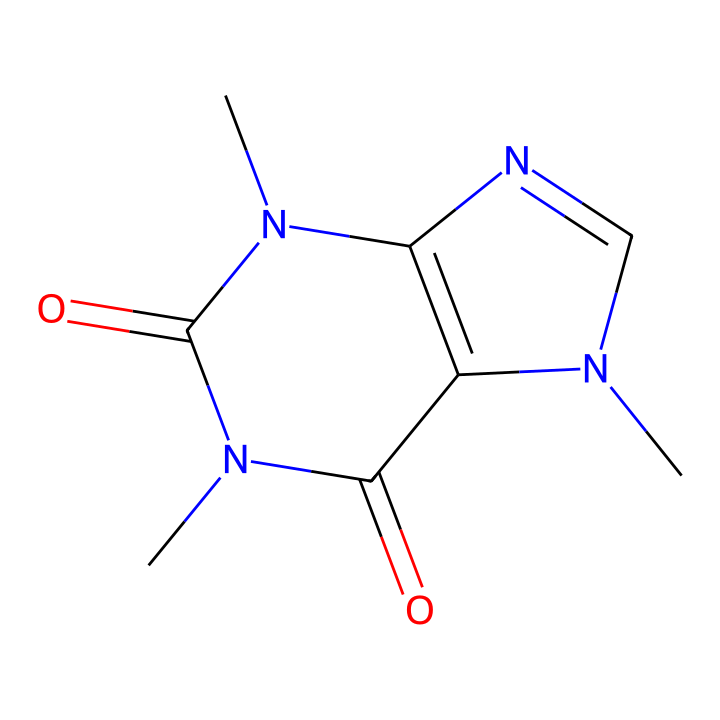What is the molecular formula of this chemical? The SMILES representation can be analyzed to count the atoms of each element. The chemical contains 8 carbon (C) atoms, 10 hydrogen (H) atoms, 4 nitrogen (N) atoms, and 2 oxygen (O) atoms. Hence, the molecular formula is C8H10N4O2.
Answer: C8H10N4O2 How many rings are present in the structure? By inspecting the structure, we can identify the cyclic parts. There are two rings formed by the nitrogen and carbon atoms in the structure, confirming that the compound is bicyclic.
Answer: 2 What type of chemical compound is caffeine? Caffeine is primarily classified as an alkaloid, which is a category of naturally occurring organic compounds that mostly contain basic nitrogen atoms. The presence of nitrogen atoms in its structure identifies it as an alkaloid.
Answer: alkaloid What are the substituents attached to the main structure? The main structure of caffeine contains methyl groups attached to the nitrogen atoms. The structure also features carbonyl groups, which are characteristic of its functional groups. Thus, the substituents are methyl groups and carbonyl groups.
Answer: methyl, carbonyl How does the presence of nitrogen influence caffeine's properties? The nitrogen atoms in caffeine contribute to its basicity and ability to interact with receptors in the brain, leading to stimulant effects. This is evidenced by the nitrogen configuration in the ring structure, which helps form hydrogen bonds with other molecules.
Answer: stimulant effects Can this chemical undergo photochemical reactions? Yes, caffeine, as a photoreactive chemical, can absorb light energy and undergo structural changes upon exposure to UV or visible light. Its ring structure and carbonyl groups are particularly significant in these photochemical processes.
Answer: yes 